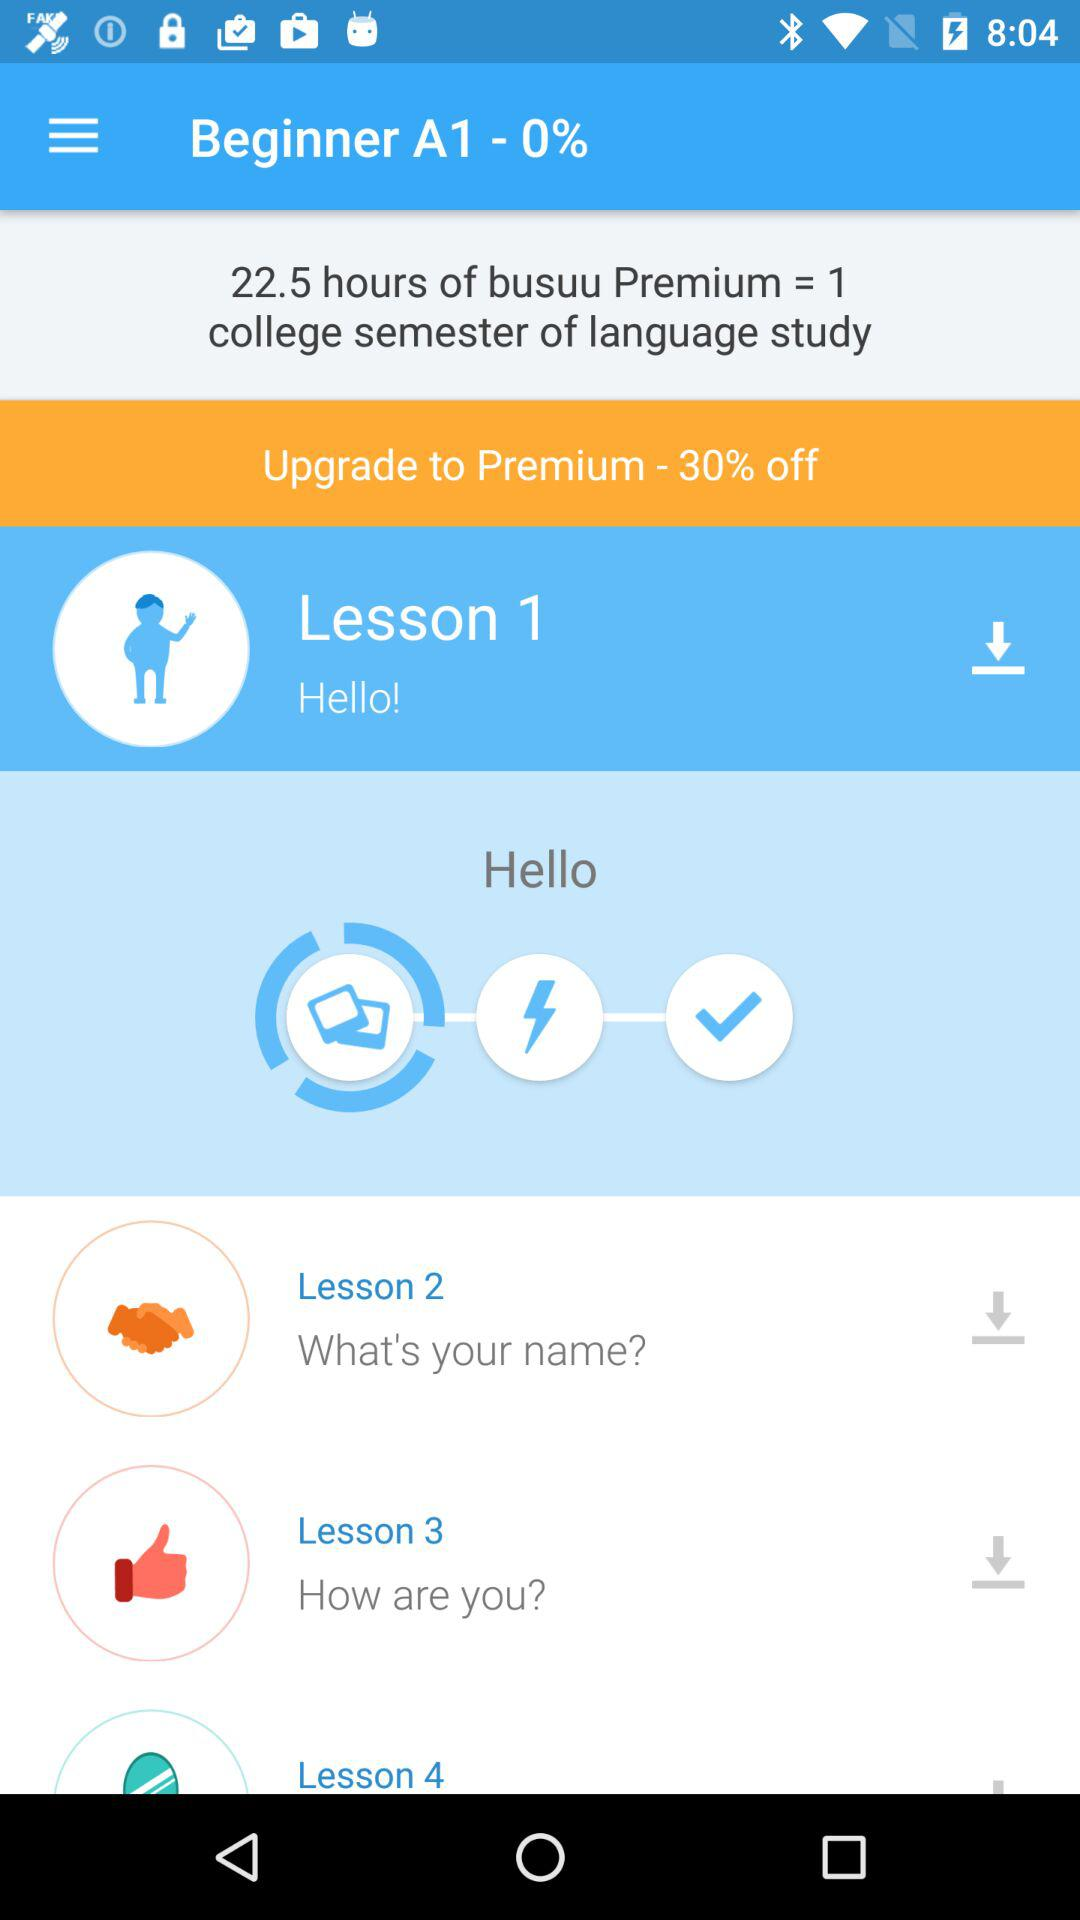How many lessons are there?
Answer the question using a single word or phrase. 4 